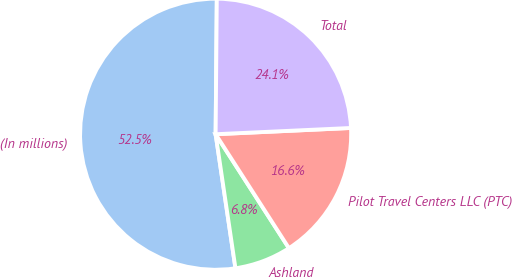<chart> <loc_0><loc_0><loc_500><loc_500><pie_chart><fcel>(In millions)<fcel>Ashland<fcel>Pilot Travel Centers LLC (PTC)<fcel>Total<nl><fcel>52.48%<fcel>6.76%<fcel>16.64%<fcel>24.13%<nl></chart> 